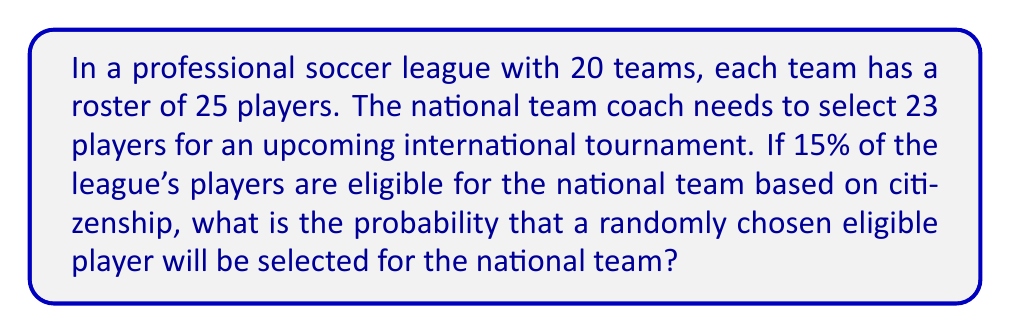What is the answer to this math problem? Let's approach this step-by-step:

1) First, calculate the total number of players in the league:
   $$ \text{Total players} = 20 \text{ teams} \times 25 \text{ players per team} = 500 \text{ players} $$

2) Calculate the number of eligible players:
   $$ \text{Eligible players} = 15\% \text{ of } 500 = 0.15 \times 500 = 75 \text{ players} $$

3) We know that 23 players will be selected for the national team from these 75 eligible players.

4) The probability of a specific eligible player being selected is:
   $$ P(\text{selected}) = \frac{\text{Number of players to be selected}}{\text{Total number of eligible players}} $$

5) Substituting the values:
   $$ P(\text{selected}) = \frac{23}{75} $$

6) Simplifying the fraction:
   $$ P(\text{selected}) = \frac{23}{75} \approx 0.3067 $$

Therefore, the probability is approximately 0.3067 or about 30.67%.
Answer: $\frac{23}{75}$ or approximately 0.3067 